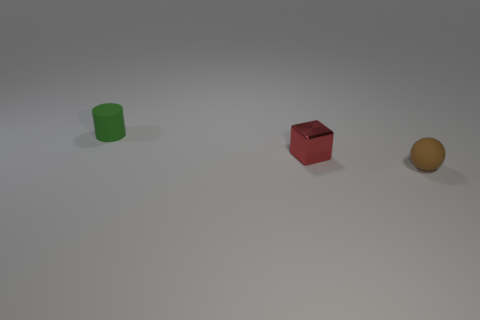Add 1 purple spheres. How many objects exist? 4 Subtract all cubes. How many objects are left? 2 Add 3 big cyan metallic cubes. How many big cyan metallic cubes exist? 3 Subtract 0 purple blocks. How many objects are left? 3 Subtract all big red metal things. Subtract all small green matte cylinders. How many objects are left? 2 Add 1 red shiny cubes. How many red shiny cubes are left? 2 